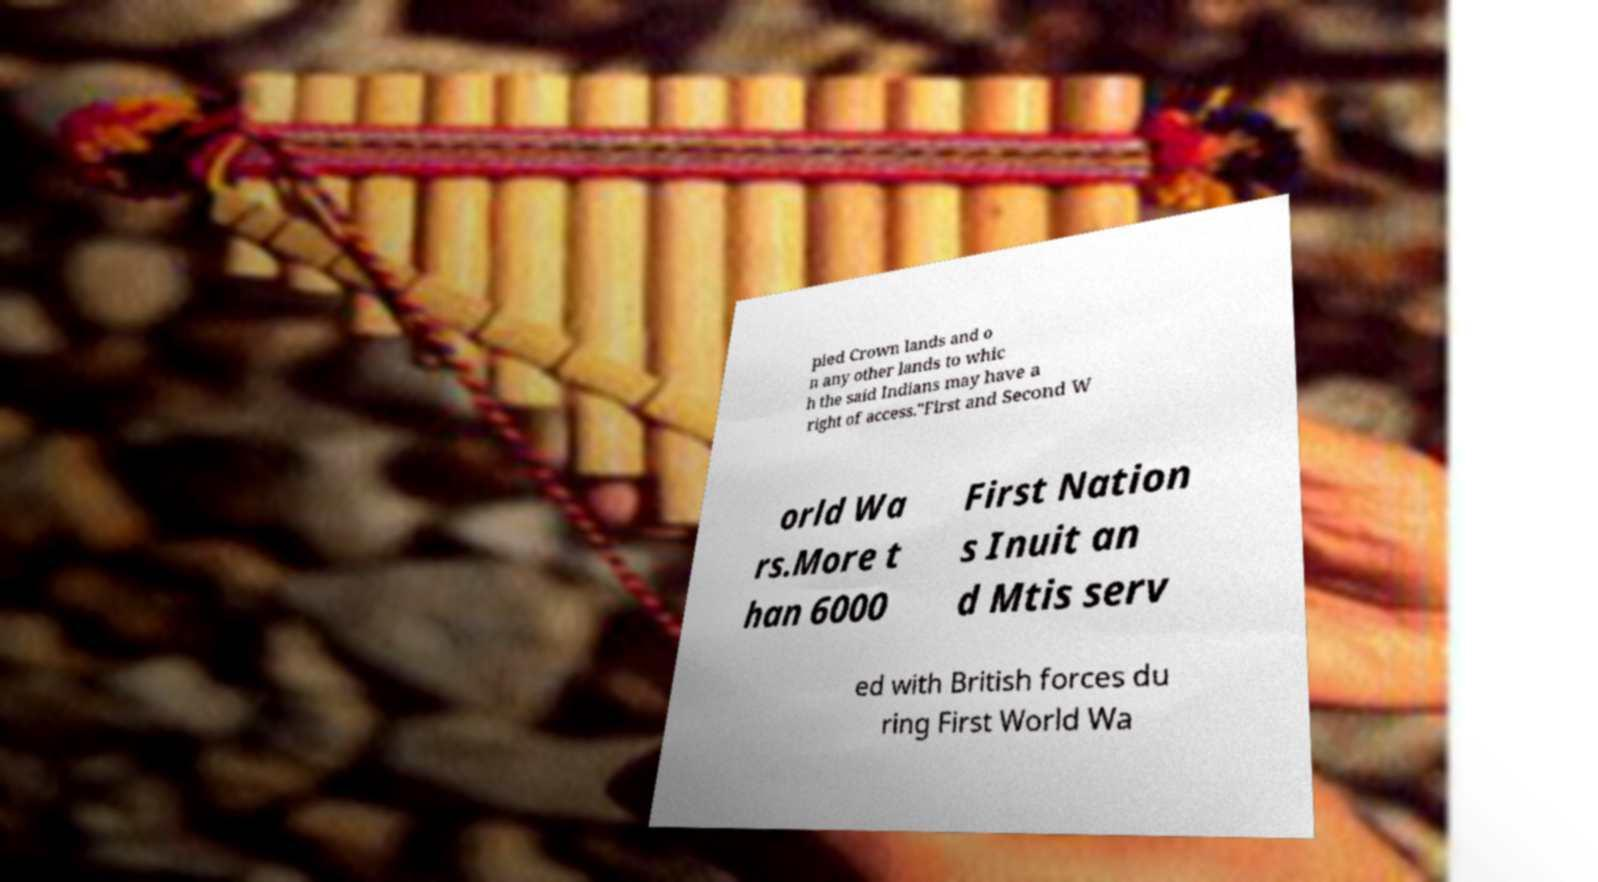Can you read and provide the text displayed in the image?This photo seems to have some interesting text. Can you extract and type it out for me? pied Crown lands and o n any other lands to whic h the said Indians may have a right of access."First and Second W orld Wa rs.More t han 6000 First Nation s Inuit an d Mtis serv ed with British forces du ring First World Wa 